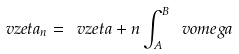<formula> <loc_0><loc_0><loc_500><loc_500>\ v z e t a _ { n } = \ v z e t a + n \int ^ { B } _ { A } \ v o m e g a</formula> 